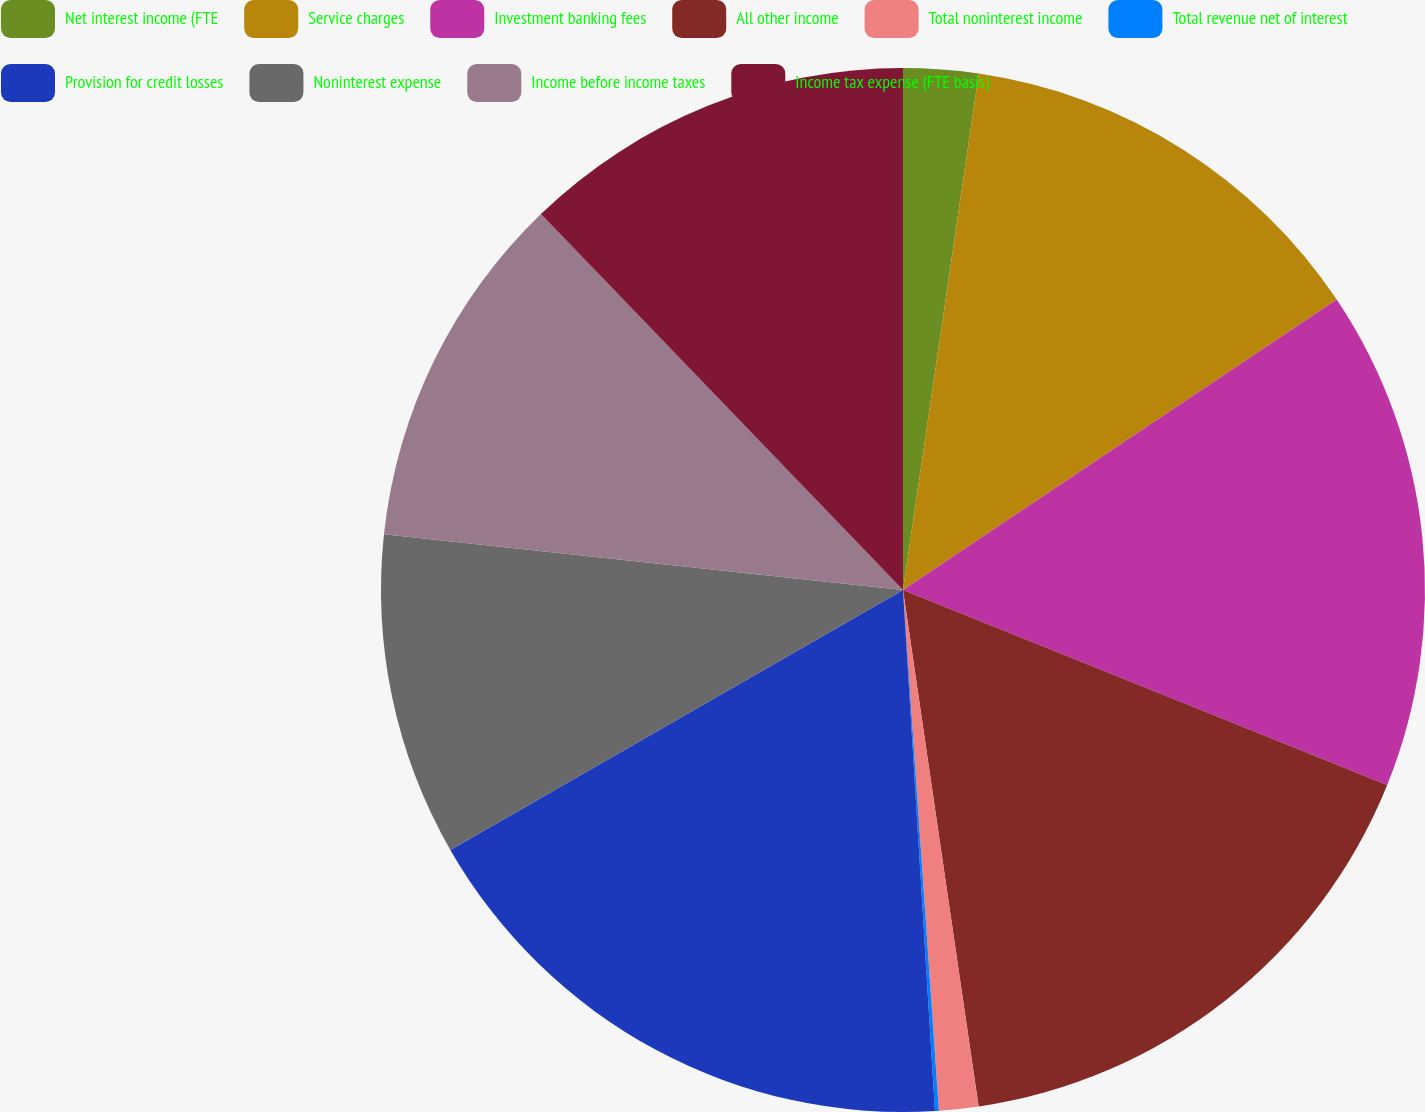Convert chart. <chart><loc_0><loc_0><loc_500><loc_500><pie_chart><fcel>Net interest income (FTE<fcel>Service charges<fcel>Investment banking fees<fcel>All other income<fcel>Total noninterest income<fcel>Total revenue net of interest<fcel>Provision for credit losses<fcel>Noninterest expense<fcel>Income before income taxes<fcel>Income tax expense (FTE basis)<nl><fcel>2.32%<fcel>13.29%<fcel>15.49%<fcel>16.59%<fcel>1.22%<fcel>0.12%<fcel>17.68%<fcel>10.0%<fcel>11.1%<fcel>12.2%<nl></chart> 